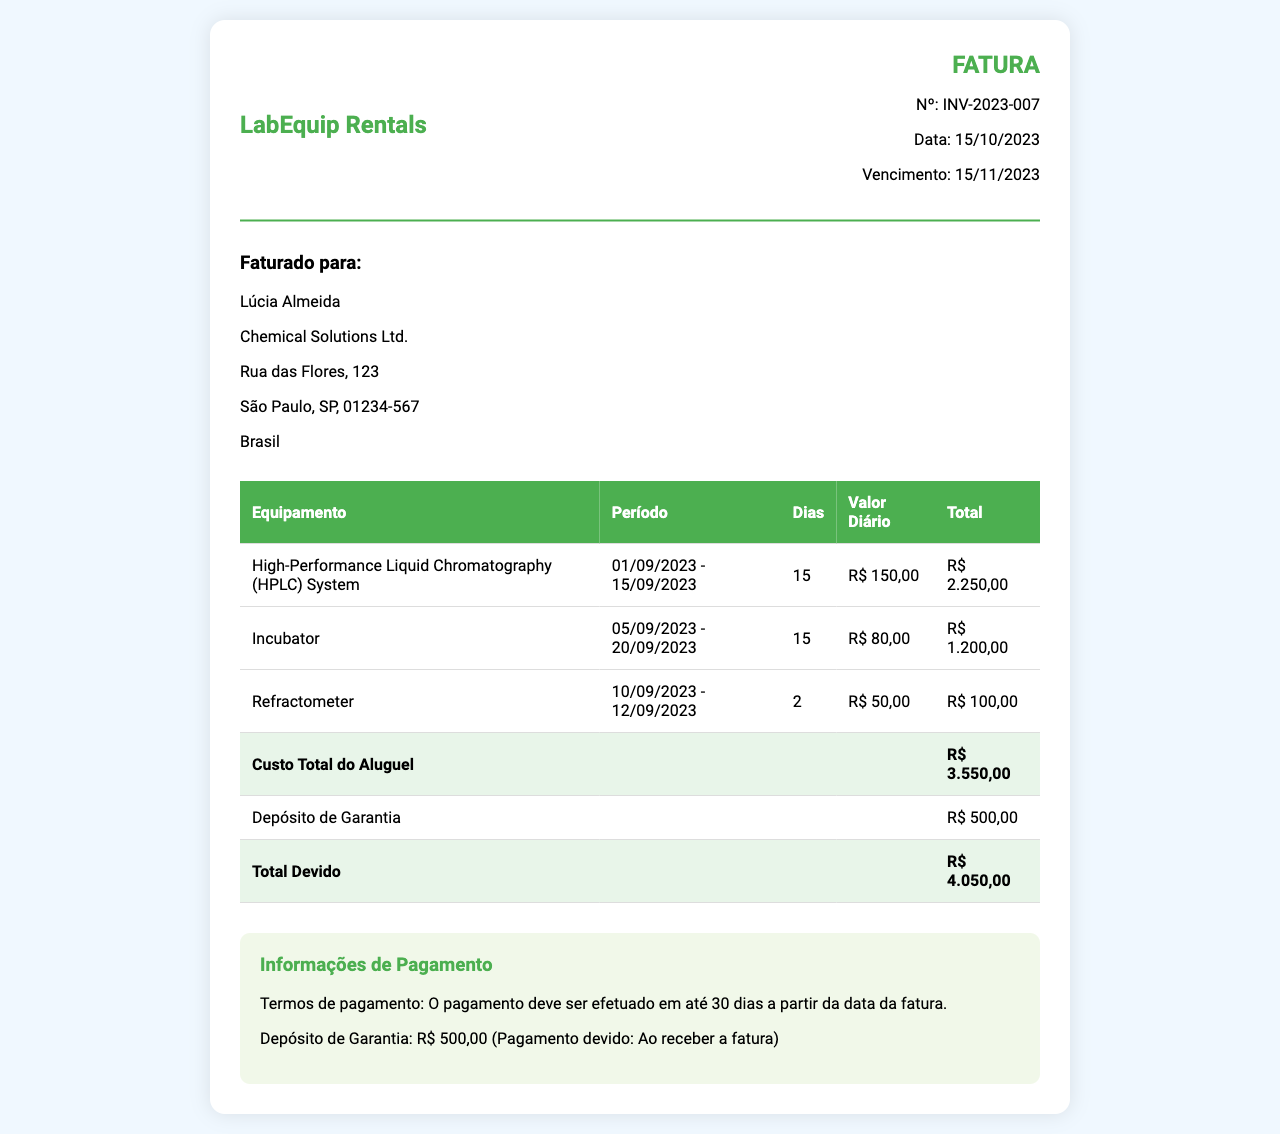what is the invoice number? The invoice number is stated clearly in the document header as "Nº: INV-2023-007".
Answer: INV-2023-007 what is the total cost of the equipment rental? The total cost of the equipment rental is found at the bottom of the table, which indicates the total as "R$ 3.550,00".
Answer: R$ 3.550,00 who is the client? The client details are provided at the top section of the document, identifying "Lúcia Almeida".
Answer: Lúcia Almeida what is the rental period for the HPLC System? The rental period for the HPLC System is shown in the table as "01/09/2023 - 15/09/2023".
Answer: 01/09/2023 - 15/09/2023 how much is the damage deposit? The document specifies the damage deposit as "R$ 500,00".
Answer: R$ 500,00 how many days was the Incubator rented? The number of days for which the Incubator was rented is specifically listed in the table as "15".
Answer: 15 what is the payment term mentioned in the document? The payment terms are outlined in the payment information section, stating "O pagamento deve ser efetuado em até 30 dias".
Answer: 30 dias what is the due date for payment? The due date is indicated in the invoice details as "15/11/2023".
Answer: 15/11/2023 what equipment had the lowest rental cost? The table shows the Refractometer as the equipment with the lowest total rental cost of "R$ 100,00".
Answer: Refractometer 